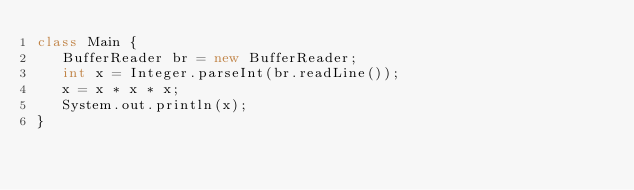<code> <loc_0><loc_0><loc_500><loc_500><_Java_>class Main {
   BufferReader br = new BufferReader;
   int x = Integer.parseInt(br.readLine());
   x = x * x * x;
   System.out.println(x);
}</code> 